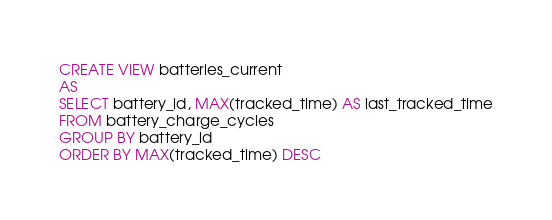Convert code to text. <code><loc_0><loc_0><loc_500><loc_500><_SQL_>CREATE VIEW batteries_current
AS
SELECT battery_id, MAX(tracked_time) AS last_tracked_time
FROM battery_charge_cycles
GROUP BY battery_id
ORDER BY MAX(tracked_time) DESC
</code> 